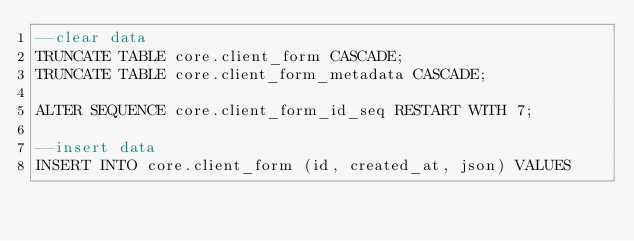Convert code to text. <code><loc_0><loc_0><loc_500><loc_500><_SQL_>--clear data
TRUNCATE TABLE core.client_form CASCADE;
TRUNCATE TABLE core.client_form_metadata CASCADE;

ALTER SEQUENCE core.client_form_id_seq RESTART WITH 7;

--insert data
INSERT INTO core.client_form (id, created_at, json) VALUES</code> 